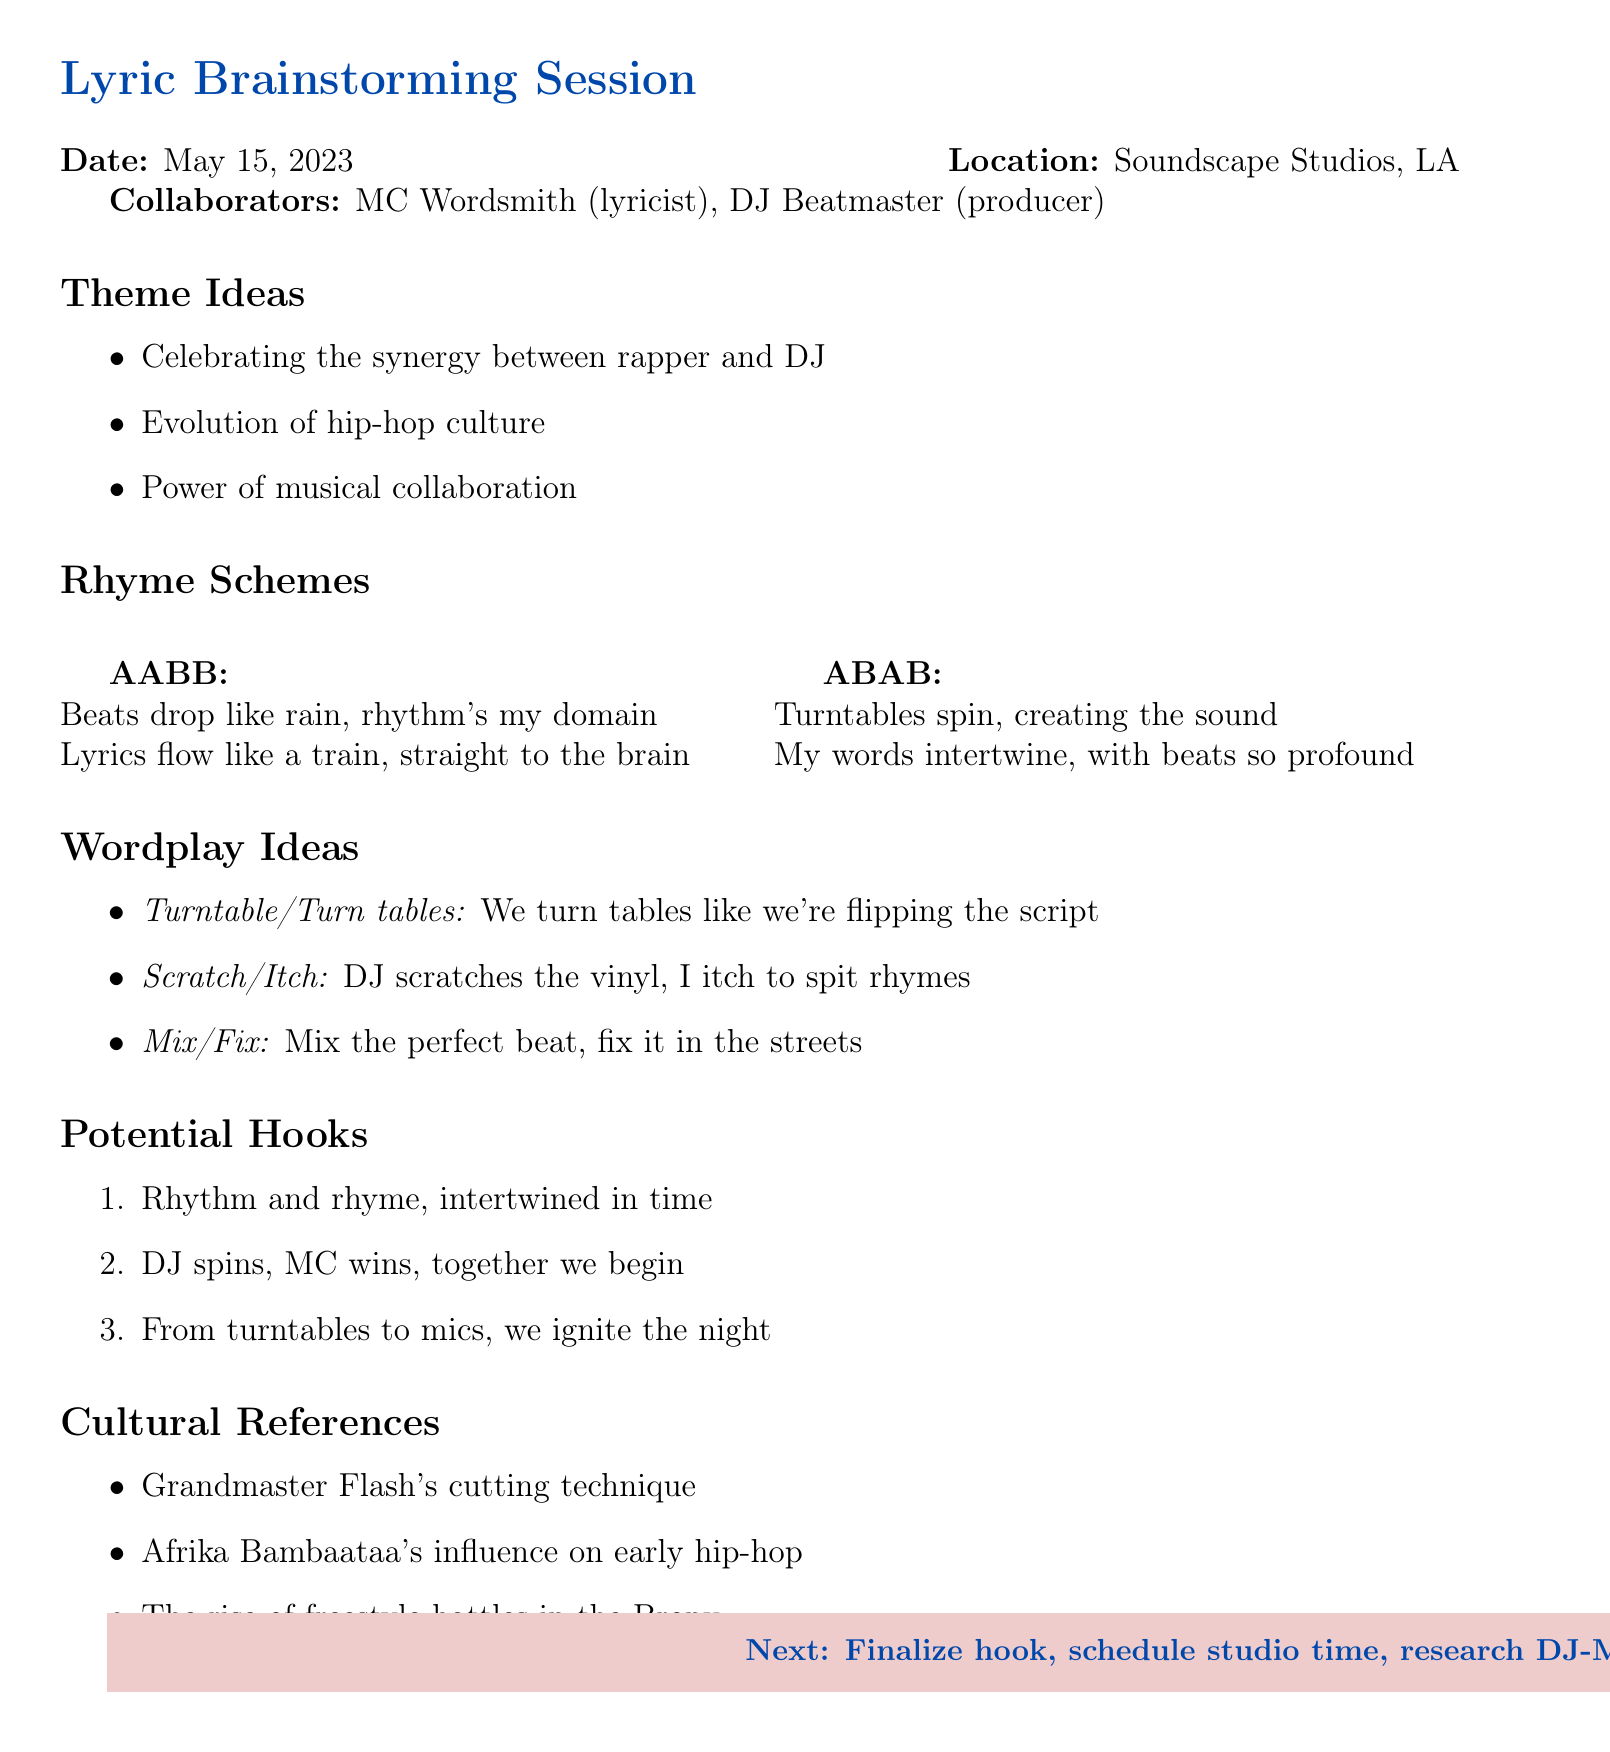What is the date of the lyric brainstorming session? The date is specified in the document as May 15, 2023.
Answer: May 15, 2023 Where did the session take place? The location of the session is noted as Soundscape Studios, Los Angeles.
Answer: Soundscape Studios, Los Angeles Who are the collaborators mentioned in the session? The document lists the names of the collaborators involved in the session.
Answer: MC Wordsmith, DJ Beatmaster What is the title of the song being worked on? The title of the song is indicated as "Rhythm & Rhyme Revolution."
Answer: Rhythm & Rhyme Revolution What is one of the theme ideas discussed? The document provides several theme ideas discussed during the session.
Answer: Celebrating the synergy between rapper and DJ What is a proposed rhyme scheme from the session? The document presents several potential rhyme schemes.
Answer: AABB Which cultural reference is mentioned in the document? The session notes include specific cultural references related to hip-hop.
Answer: Grandmaster Flash's cutting technique What are the next steps indicated in the memo? The document outlines the next steps to be taken after the session.
Answer: Finalize hook and verse structure 